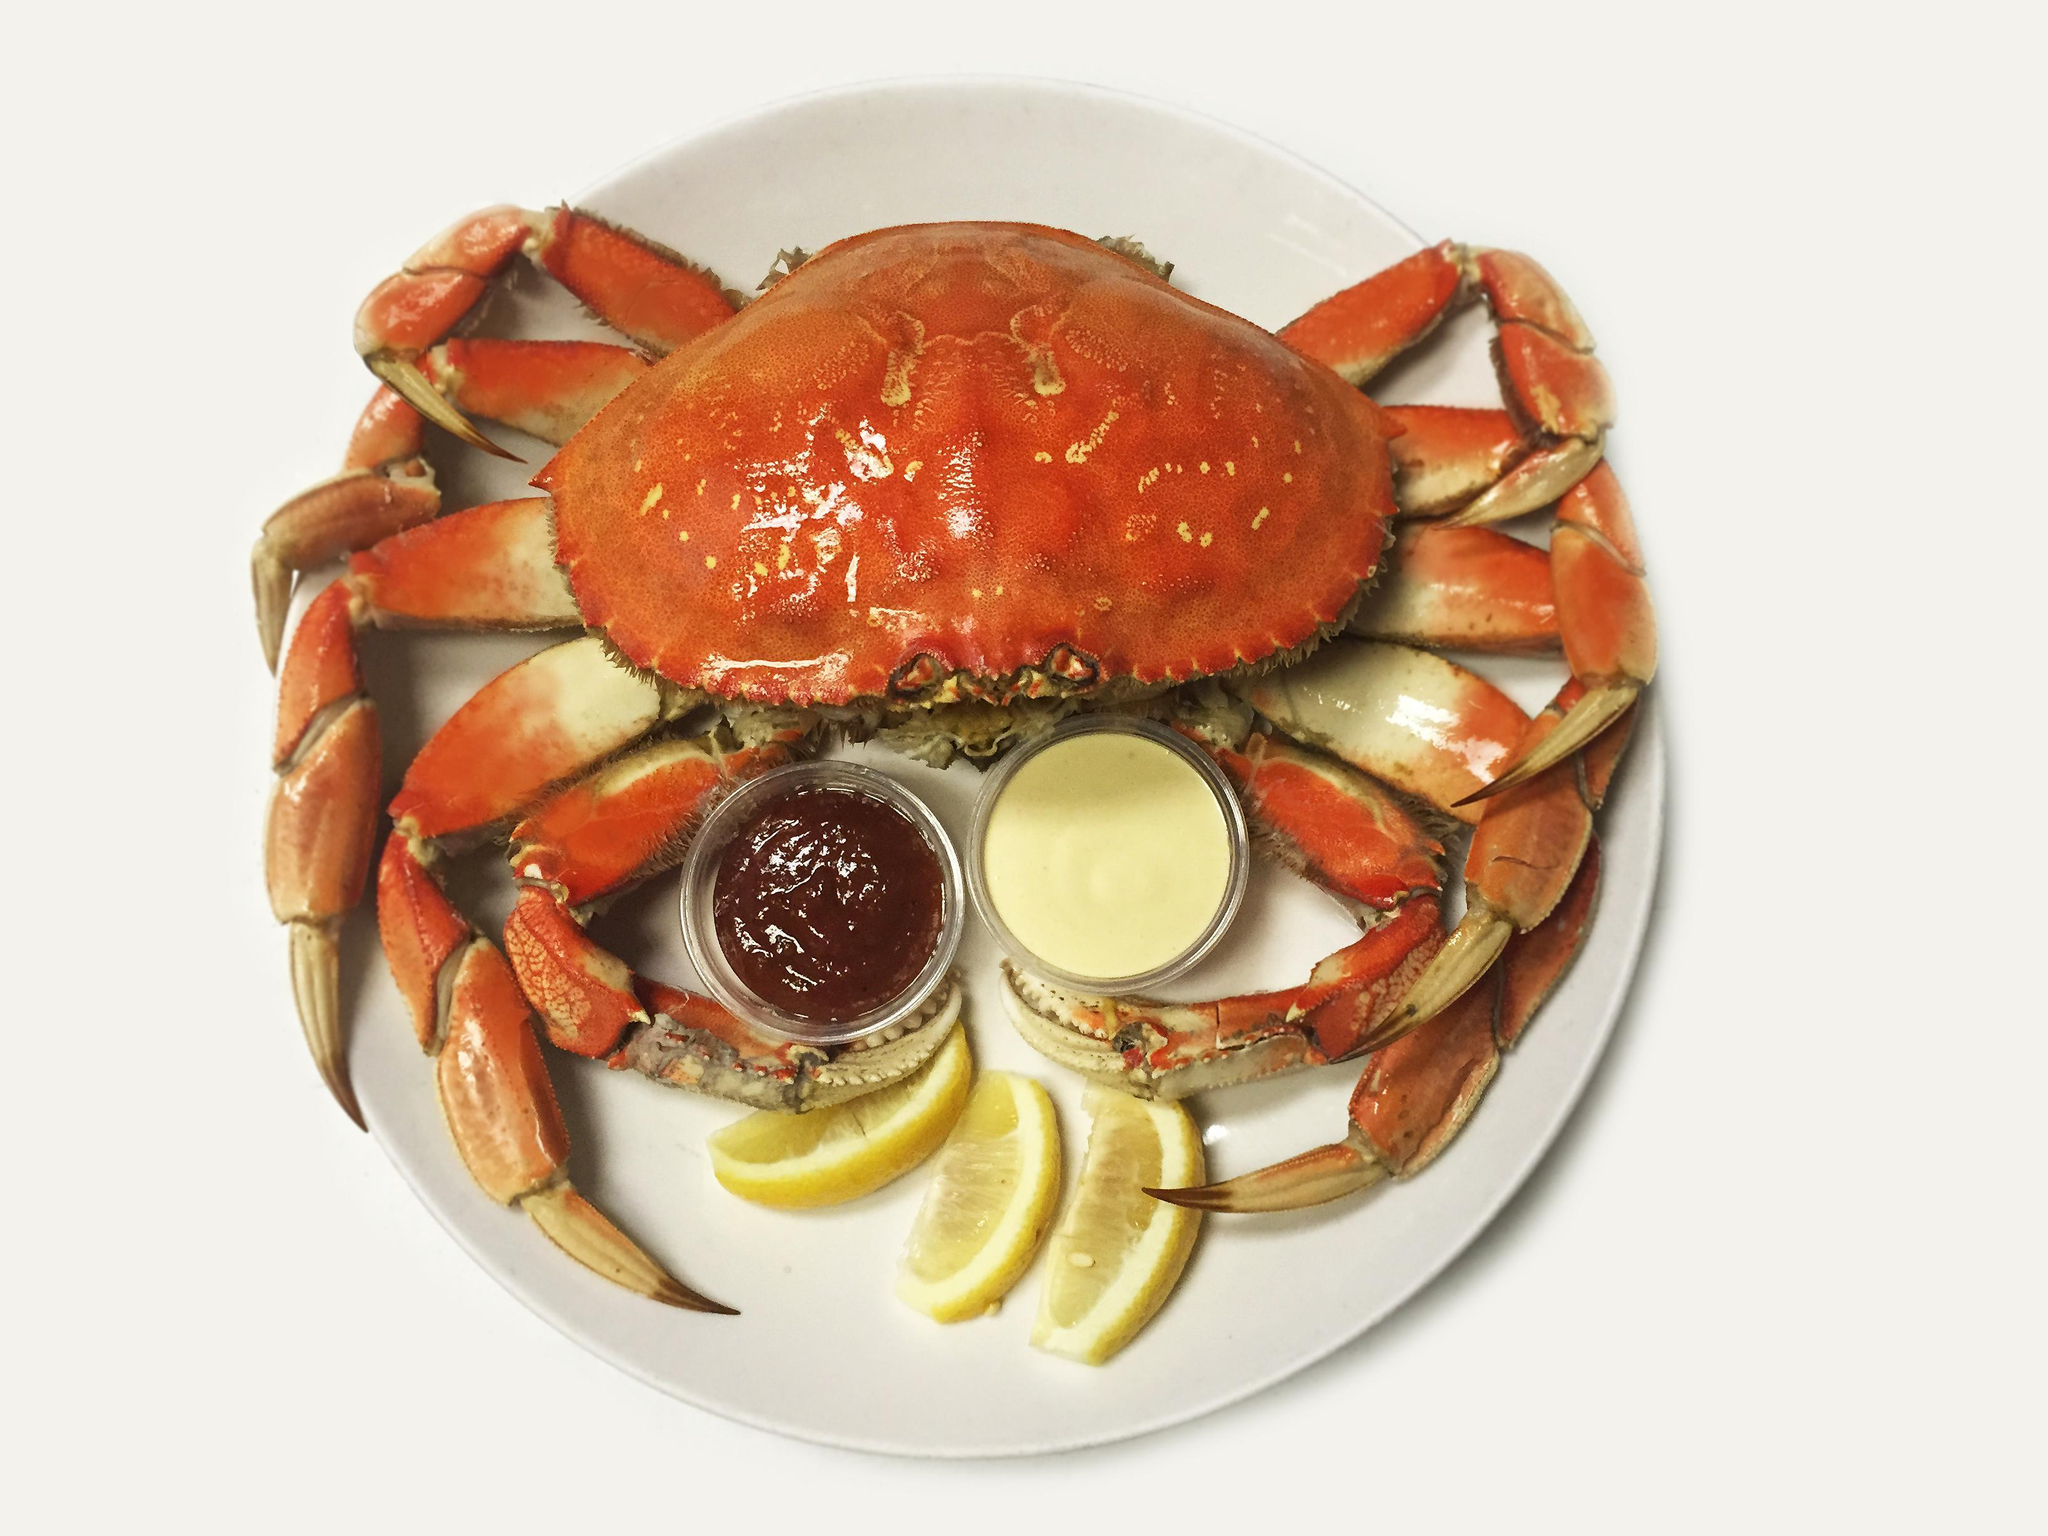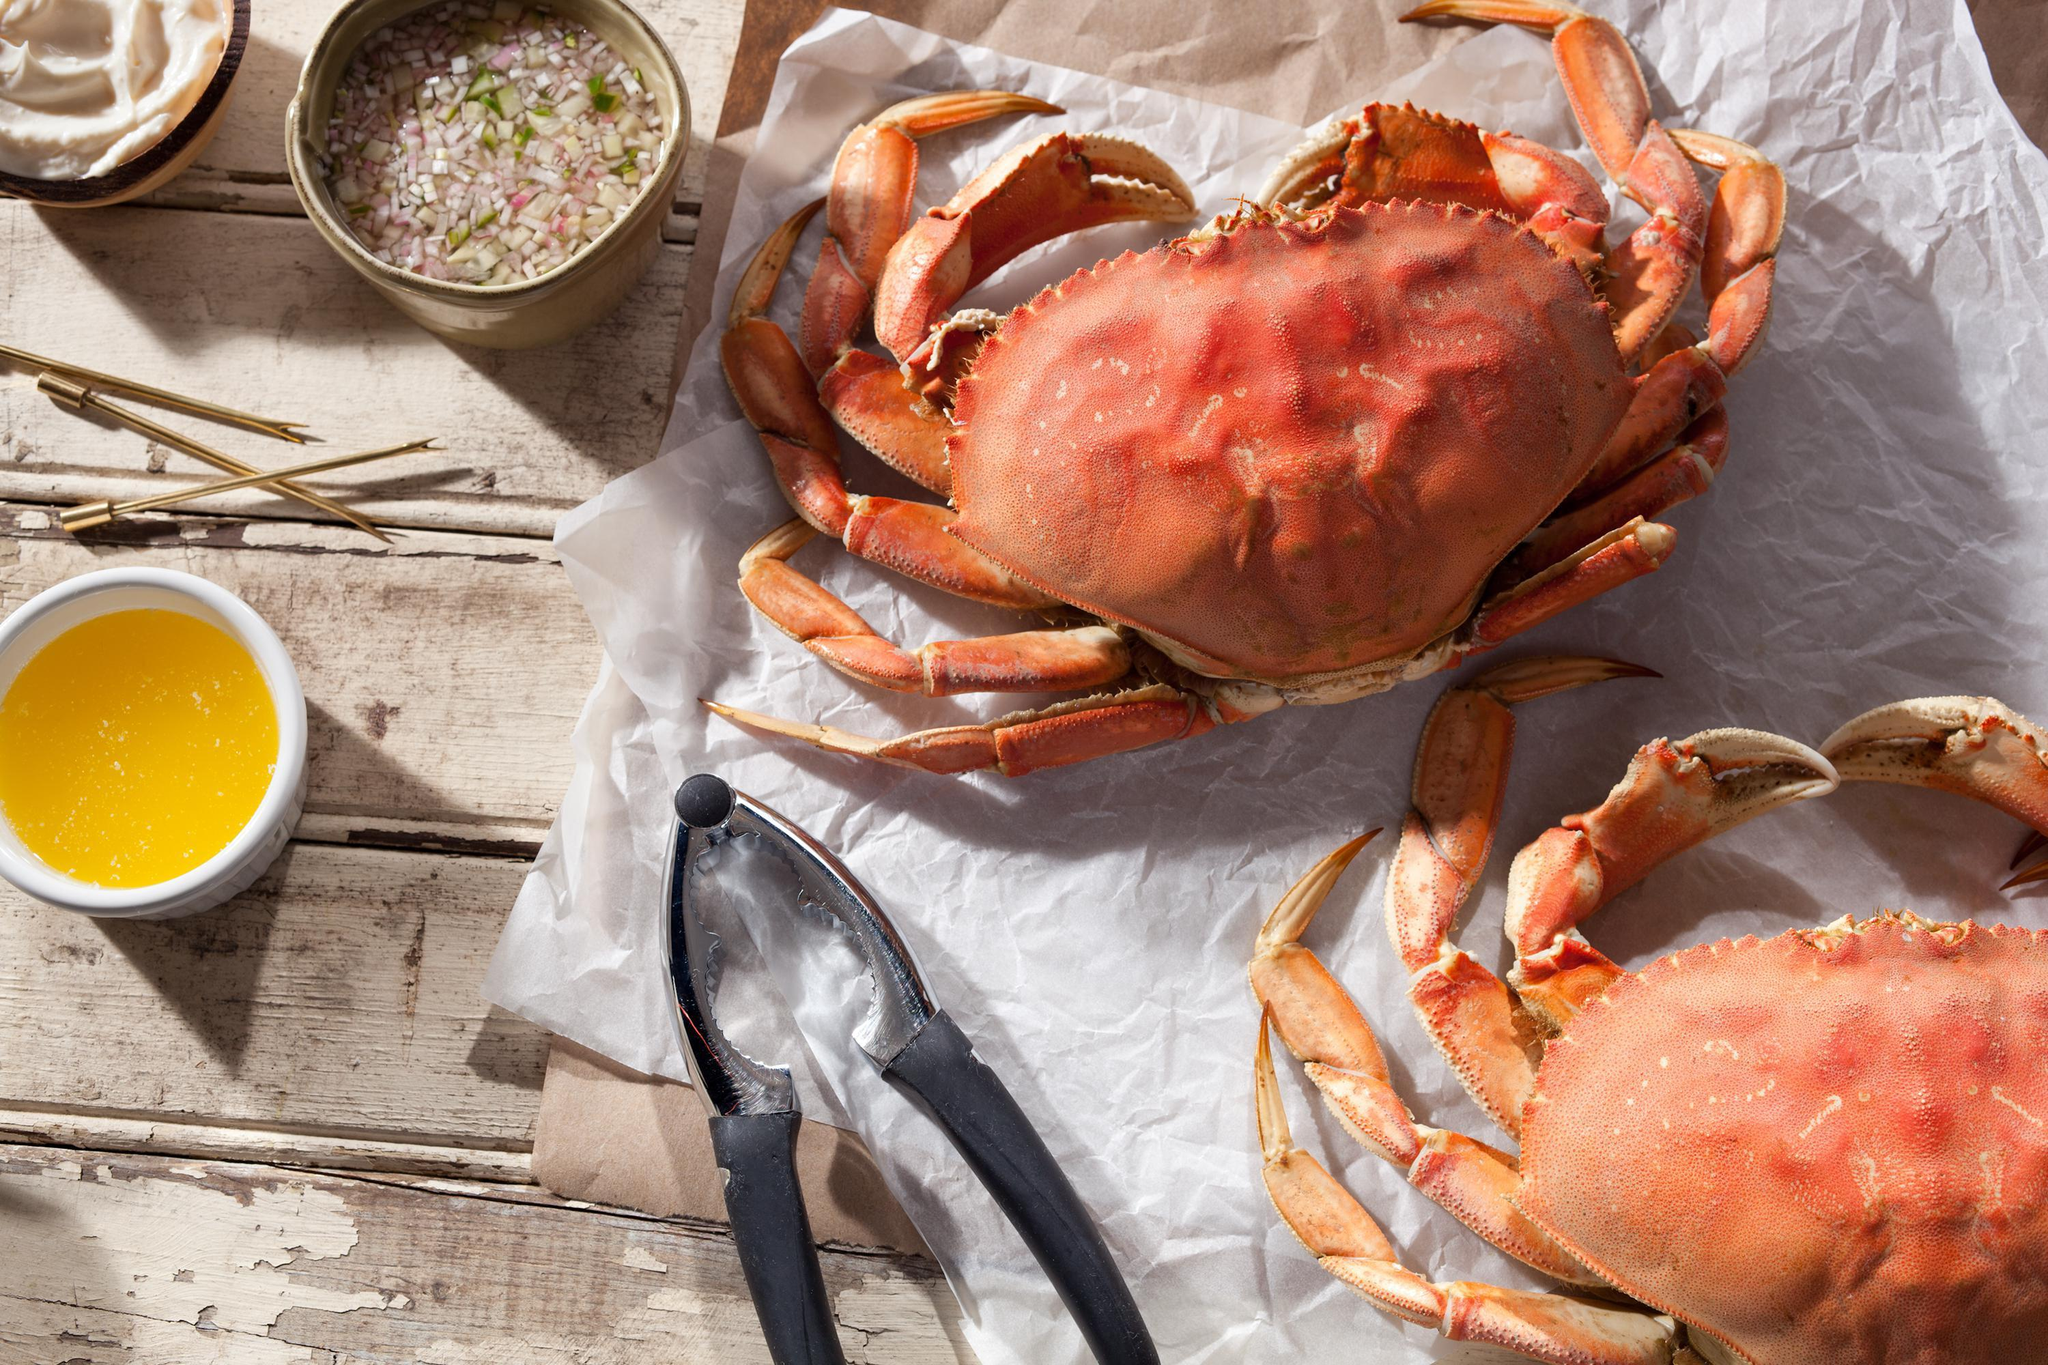The first image is the image on the left, the second image is the image on the right. Given the left and right images, does the statement "In the image on the right, a person is pulling apart the crab to expose its meat." hold true? Answer yes or no. No. The first image is the image on the left, the second image is the image on the right. Assess this claim about the two images: "Atleast one image of a crab split down the middle.". Correct or not? Answer yes or no. No. 